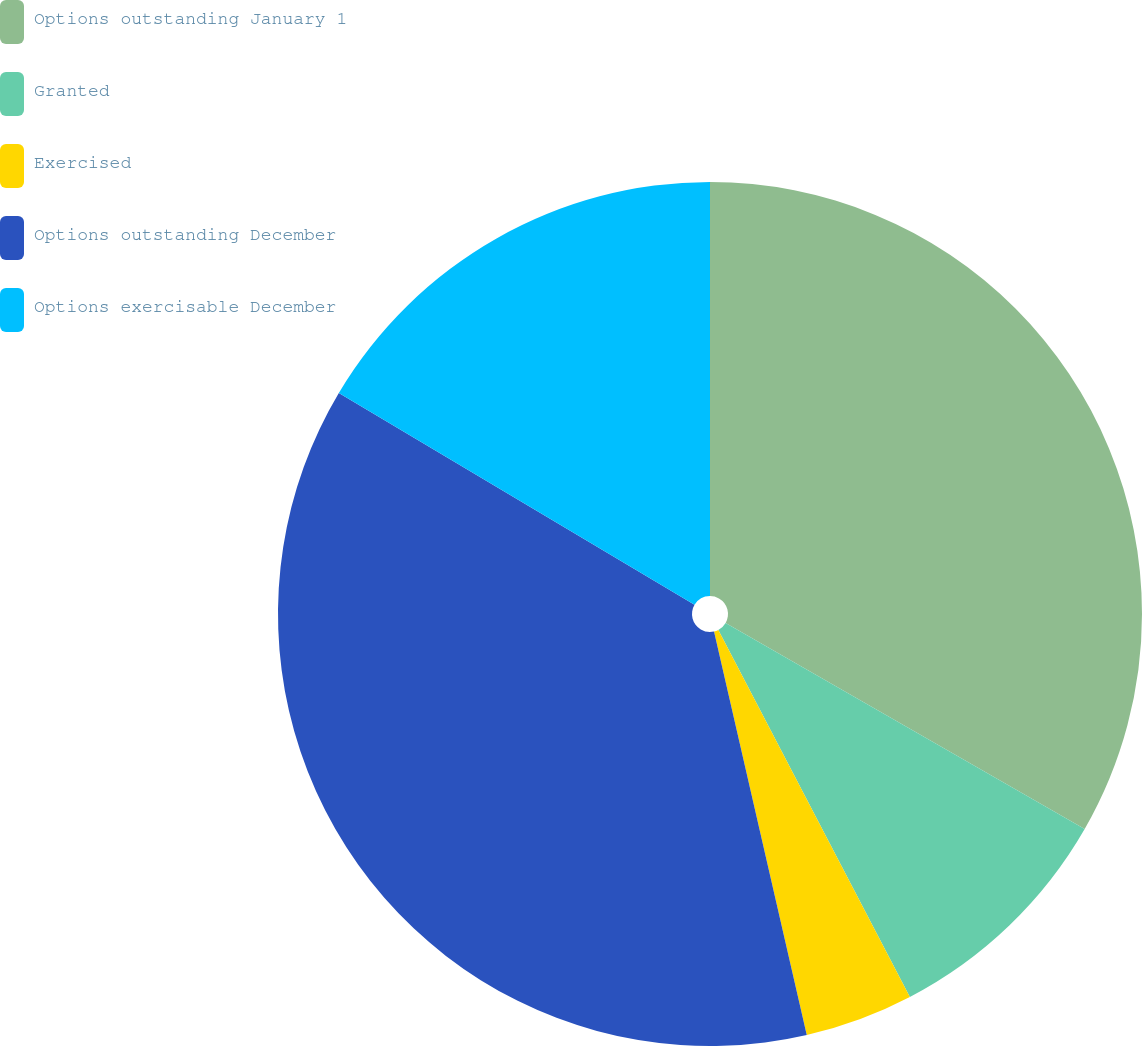Convert chart. <chart><loc_0><loc_0><loc_500><loc_500><pie_chart><fcel>Options outstanding January 1<fcel>Granted<fcel>Exercised<fcel>Options outstanding December<fcel>Options exercisable December<nl><fcel>33.29%<fcel>9.05%<fcel>4.06%<fcel>37.14%<fcel>16.45%<nl></chart> 